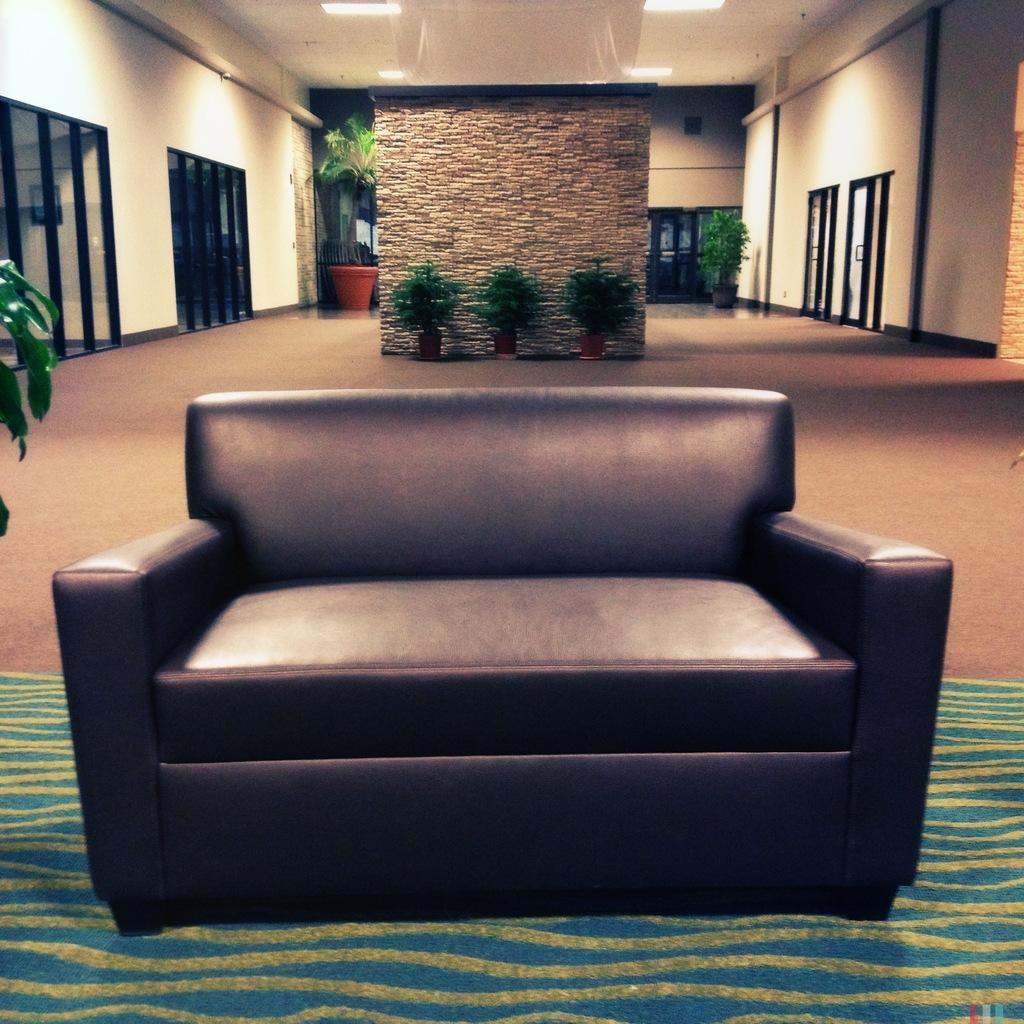What type of furniture is present in the image? There is a sofa in the image. What color is the carpet in the image? The carpet in the image is blue. What type of plants are in the image? There are tree pots in the image. What can be seen on the wall in the image? There are glasses on both sides of the wall in the image. What is on top of the room in the image? There is a roof with lights in the image. Is there a guitar leaning against the sofa in the image? No, there is no guitar present in the image. What is the condition of the crack in the wall in the image? There is no crack mentioned in the image, so we cannot answer a question about its condition. 